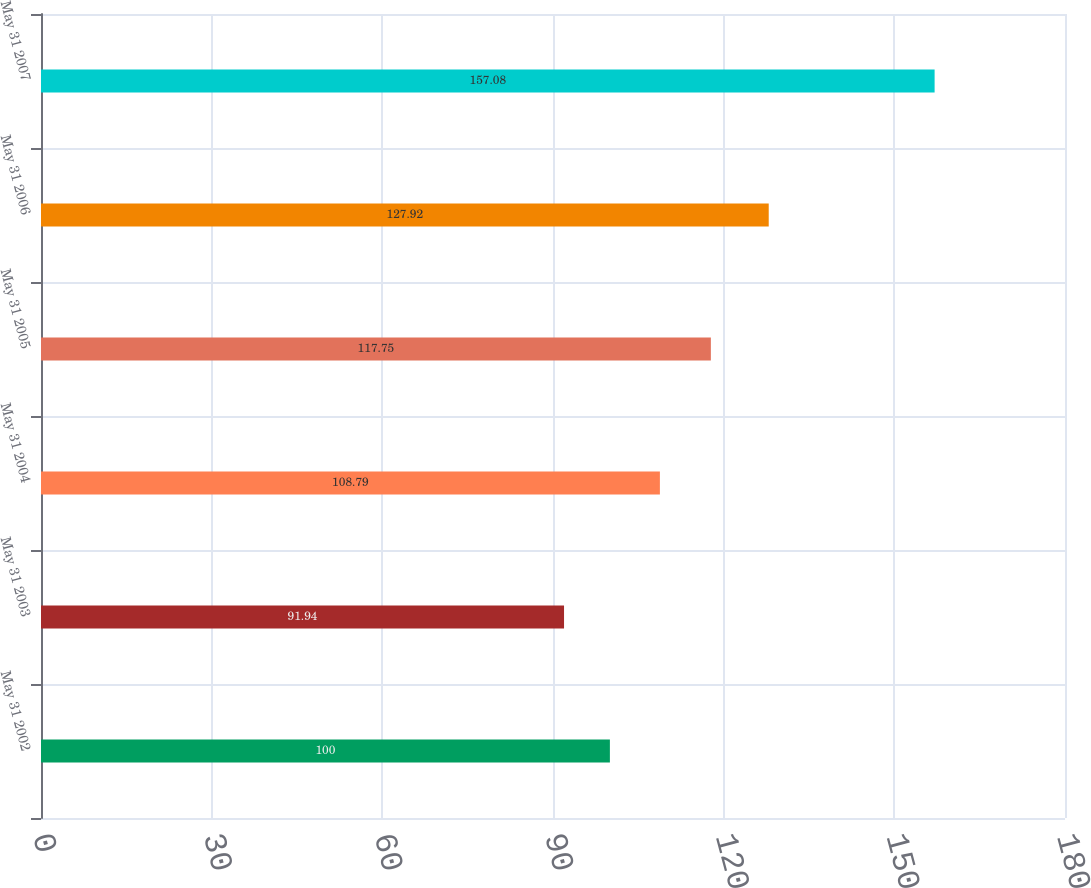Convert chart. <chart><loc_0><loc_0><loc_500><loc_500><bar_chart><fcel>May 31 2002<fcel>May 31 2003<fcel>May 31 2004<fcel>May 31 2005<fcel>May 31 2006<fcel>May 31 2007<nl><fcel>100<fcel>91.94<fcel>108.79<fcel>117.75<fcel>127.92<fcel>157.08<nl></chart> 